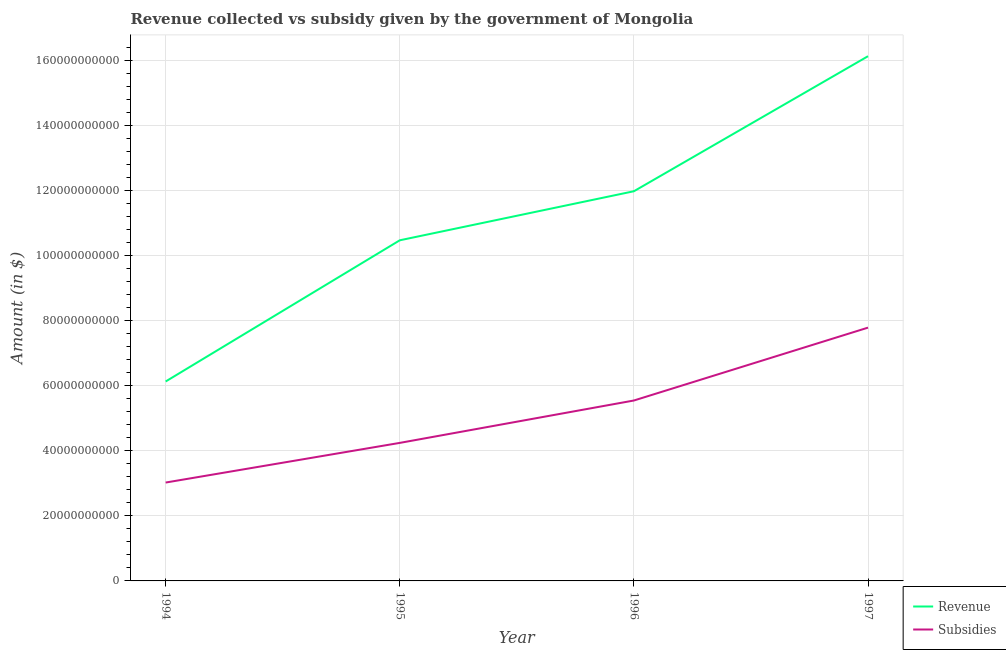Does the line corresponding to amount of subsidies given intersect with the line corresponding to amount of revenue collected?
Ensure brevity in your answer.  No. Is the number of lines equal to the number of legend labels?
Provide a succinct answer. Yes. What is the amount of revenue collected in 1995?
Offer a very short reply. 1.05e+11. Across all years, what is the maximum amount of subsidies given?
Keep it short and to the point. 7.79e+1. Across all years, what is the minimum amount of subsidies given?
Give a very brief answer. 3.03e+1. What is the total amount of revenue collected in the graph?
Ensure brevity in your answer.  4.47e+11. What is the difference between the amount of subsidies given in 1994 and that in 1995?
Ensure brevity in your answer.  -1.22e+1. What is the difference between the amount of revenue collected in 1994 and the amount of subsidies given in 1995?
Offer a terse response. 1.89e+1. What is the average amount of revenue collected per year?
Keep it short and to the point. 1.12e+11. In the year 1997, what is the difference between the amount of revenue collected and amount of subsidies given?
Your answer should be compact. 8.35e+1. What is the ratio of the amount of revenue collected in 1994 to that in 1997?
Provide a succinct answer. 0.38. Is the amount of subsidies given in 1994 less than that in 1997?
Offer a very short reply. Yes. What is the difference between the highest and the second highest amount of revenue collected?
Give a very brief answer. 4.15e+1. What is the difference between the highest and the lowest amount of revenue collected?
Provide a short and direct response. 1.00e+11. In how many years, is the amount of revenue collected greater than the average amount of revenue collected taken over all years?
Make the answer very short. 2. Is the sum of the amount of revenue collected in 1994 and 1997 greater than the maximum amount of subsidies given across all years?
Provide a short and direct response. Yes. Does the amount of subsidies given monotonically increase over the years?
Make the answer very short. Yes. Is the amount of subsidies given strictly greater than the amount of revenue collected over the years?
Provide a succinct answer. No. Is the amount of revenue collected strictly less than the amount of subsidies given over the years?
Your response must be concise. No. How many years are there in the graph?
Your response must be concise. 4. Are the values on the major ticks of Y-axis written in scientific E-notation?
Your answer should be compact. No. Does the graph contain any zero values?
Provide a short and direct response. No. Does the graph contain grids?
Provide a short and direct response. Yes. Where does the legend appear in the graph?
Make the answer very short. Bottom right. How are the legend labels stacked?
Provide a succinct answer. Vertical. What is the title of the graph?
Provide a short and direct response. Revenue collected vs subsidy given by the government of Mongolia. Does "Electricity and heat production" appear as one of the legend labels in the graph?
Ensure brevity in your answer.  No. What is the label or title of the X-axis?
Ensure brevity in your answer.  Year. What is the label or title of the Y-axis?
Your answer should be compact. Amount (in $). What is the Amount (in $) of Revenue in 1994?
Your response must be concise. 6.13e+1. What is the Amount (in $) in Subsidies in 1994?
Offer a terse response. 3.03e+1. What is the Amount (in $) of Revenue in 1995?
Your answer should be compact. 1.05e+11. What is the Amount (in $) of Subsidies in 1995?
Offer a very short reply. 4.24e+1. What is the Amount (in $) in Revenue in 1996?
Your answer should be compact. 1.20e+11. What is the Amount (in $) of Subsidies in 1996?
Your response must be concise. 5.55e+1. What is the Amount (in $) in Revenue in 1997?
Make the answer very short. 1.61e+11. What is the Amount (in $) in Subsidies in 1997?
Ensure brevity in your answer.  7.79e+1. Across all years, what is the maximum Amount (in $) in Revenue?
Your response must be concise. 1.61e+11. Across all years, what is the maximum Amount (in $) in Subsidies?
Your answer should be very brief. 7.79e+1. Across all years, what is the minimum Amount (in $) of Revenue?
Give a very brief answer. 6.13e+1. Across all years, what is the minimum Amount (in $) in Subsidies?
Your answer should be very brief. 3.03e+1. What is the total Amount (in $) in Revenue in the graph?
Your answer should be very brief. 4.47e+11. What is the total Amount (in $) of Subsidies in the graph?
Give a very brief answer. 2.06e+11. What is the difference between the Amount (in $) of Revenue in 1994 and that in 1995?
Provide a succinct answer. -4.34e+1. What is the difference between the Amount (in $) in Subsidies in 1994 and that in 1995?
Provide a succinct answer. -1.22e+1. What is the difference between the Amount (in $) of Revenue in 1994 and that in 1996?
Offer a very short reply. -5.85e+1. What is the difference between the Amount (in $) of Subsidies in 1994 and that in 1996?
Your answer should be very brief. -2.52e+1. What is the difference between the Amount (in $) in Revenue in 1994 and that in 1997?
Give a very brief answer. -1.00e+11. What is the difference between the Amount (in $) of Subsidies in 1994 and that in 1997?
Offer a very short reply. -4.76e+1. What is the difference between the Amount (in $) of Revenue in 1995 and that in 1996?
Give a very brief answer. -1.51e+1. What is the difference between the Amount (in $) in Subsidies in 1995 and that in 1996?
Provide a short and direct response. -1.30e+1. What is the difference between the Amount (in $) in Revenue in 1995 and that in 1997?
Provide a short and direct response. -5.66e+1. What is the difference between the Amount (in $) of Subsidies in 1995 and that in 1997?
Your response must be concise. -3.54e+1. What is the difference between the Amount (in $) of Revenue in 1996 and that in 1997?
Your answer should be very brief. -4.15e+1. What is the difference between the Amount (in $) of Subsidies in 1996 and that in 1997?
Your response must be concise. -2.24e+1. What is the difference between the Amount (in $) in Revenue in 1994 and the Amount (in $) in Subsidies in 1995?
Provide a short and direct response. 1.89e+1. What is the difference between the Amount (in $) in Revenue in 1994 and the Amount (in $) in Subsidies in 1996?
Give a very brief answer. 5.85e+09. What is the difference between the Amount (in $) of Revenue in 1994 and the Amount (in $) of Subsidies in 1997?
Provide a succinct answer. -1.66e+1. What is the difference between the Amount (in $) of Revenue in 1995 and the Amount (in $) of Subsidies in 1996?
Offer a very short reply. 4.93e+1. What is the difference between the Amount (in $) of Revenue in 1995 and the Amount (in $) of Subsidies in 1997?
Ensure brevity in your answer.  2.69e+1. What is the difference between the Amount (in $) in Revenue in 1996 and the Amount (in $) in Subsidies in 1997?
Your response must be concise. 4.19e+1. What is the average Amount (in $) of Revenue per year?
Keep it short and to the point. 1.12e+11. What is the average Amount (in $) in Subsidies per year?
Provide a succinct answer. 5.15e+1. In the year 1994, what is the difference between the Amount (in $) of Revenue and Amount (in $) of Subsidies?
Your answer should be compact. 3.11e+1. In the year 1995, what is the difference between the Amount (in $) of Revenue and Amount (in $) of Subsidies?
Your answer should be very brief. 6.23e+1. In the year 1996, what is the difference between the Amount (in $) of Revenue and Amount (in $) of Subsidies?
Offer a terse response. 6.44e+1. In the year 1997, what is the difference between the Amount (in $) of Revenue and Amount (in $) of Subsidies?
Your answer should be very brief. 8.35e+1. What is the ratio of the Amount (in $) in Revenue in 1994 to that in 1995?
Your answer should be very brief. 0.59. What is the ratio of the Amount (in $) of Subsidies in 1994 to that in 1995?
Your response must be concise. 0.71. What is the ratio of the Amount (in $) of Revenue in 1994 to that in 1996?
Offer a very short reply. 0.51. What is the ratio of the Amount (in $) of Subsidies in 1994 to that in 1996?
Keep it short and to the point. 0.55. What is the ratio of the Amount (in $) in Revenue in 1994 to that in 1997?
Keep it short and to the point. 0.38. What is the ratio of the Amount (in $) in Subsidies in 1994 to that in 1997?
Your answer should be compact. 0.39. What is the ratio of the Amount (in $) of Revenue in 1995 to that in 1996?
Provide a short and direct response. 0.87. What is the ratio of the Amount (in $) in Subsidies in 1995 to that in 1996?
Keep it short and to the point. 0.77. What is the ratio of the Amount (in $) in Revenue in 1995 to that in 1997?
Offer a terse response. 0.65. What is the ratio of the Amount (in $) of Subsidies in 1995 to that in 1997?
Your answer should be compact. 0.55. What is the ratio of the Amount (in $) in Revenue in 1996 to that in 1997?
Provide a succinct answer. 0.74. What is the ratio of the Amount (in $) in Subsidies in 1996 to that in 1997?
Make the answer very short. 0.71. What is the difference between the highest and the second highest Amount (in $) of Revenue?
Provide a short and direct response. 4.15e+1. What is the difference between the highest and the second highest Amount (in $) of Subsidies?
Offer a very short reply. 2.24e+1. What is the difference between the highest and the lowest Amount (in $) in Revenue?
Give a very brief answer. 1.00e+11. What is the difference between the highest and the lowest Amount (in $) in Subsidies?
Ensure brevity in your answer.  4.76e+1. 